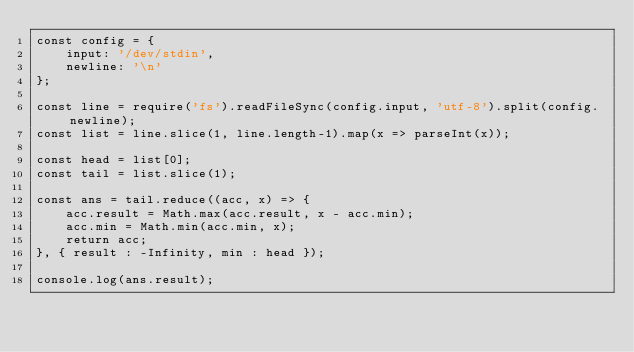Convert code to text. <code><loc_0><loc_0><loc_500><loc_500><_JavaScript_>const config = {
    input: '/dev/stdin',
    newline: '\n'
};

const line = require('fs').readFileSync(config.input, 'utf-8').split(config.newline);
const list = line.slice(1, line.length-1).map(x => parseInt(x));

const head = list[0];
const tail = list.slice(1);

const ans = tail.reduce((acc, x) => {
    acc.result = Math.max(acc.result, x - acc.min);
    acc.min = Math.min(acc.min, x);
    return acc;
}, { result : -Infinity, min : head });

console.log(ans.result);
</code> 